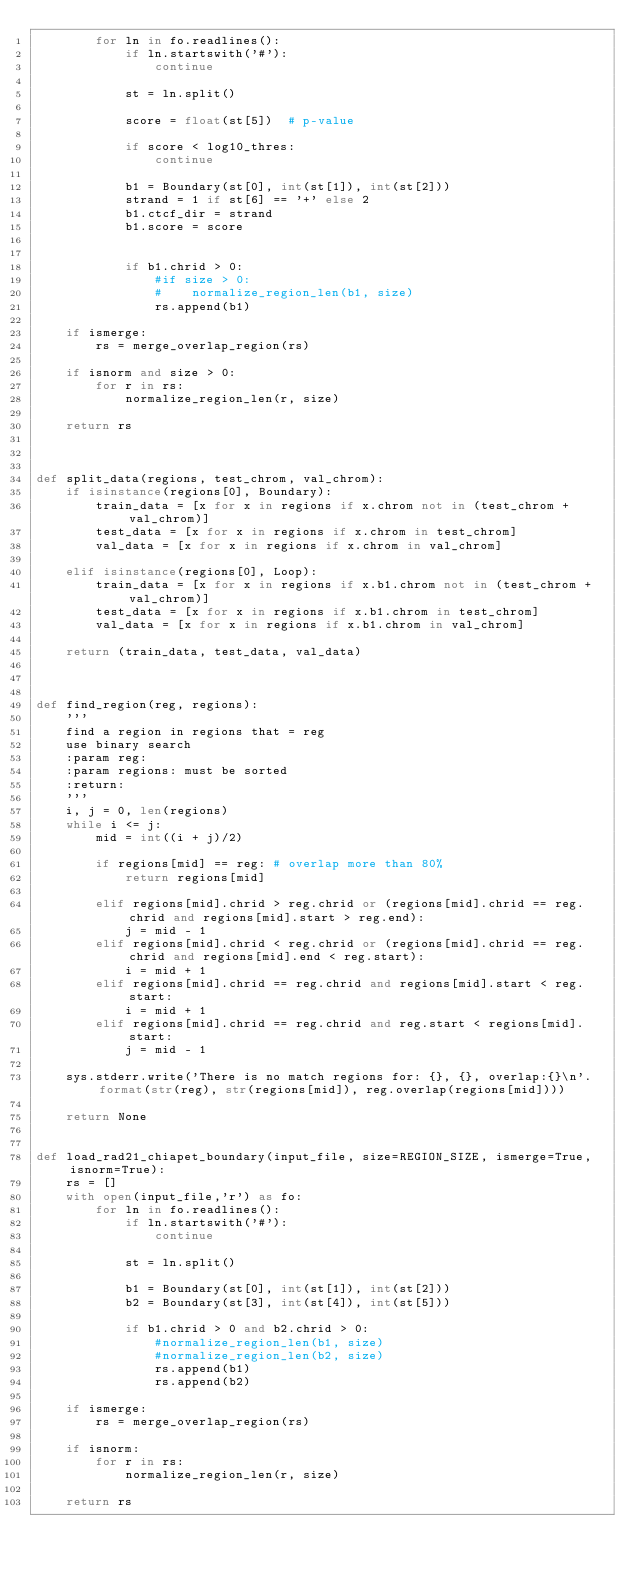<code> <loc_0><loc_0><loc_500><loc_500><_Python_>        for ln in fo.readlines():
            if ln.startswith('#'):
                continue

            st = ln.split()

            score = float(st[5])  # p-value

            if score < log10_thres:
                continue

            b1 = Boundary(st[0], int(st[1]), int(st[2]))
            strand = 1 if st[6] == '+' else 2
            b1.ctcf_dir = strand
            b1.score = score


            if b1.chrid > 0:
                #if size > 0:
                #    normalize_region_len(b1, size)
                rs.append(b1)

    if ismerge:
        rs = merge_overlap_region(rs)

    if isnorm and size > 0:
        for r in rs:
            normalize_region_len(r, size)

    return rs



def split_data(regions, test_chrom, val_chrom):
    if isinstance(regions[0], Boundary):
        train_data = [x for x in regions if x.chrom not in (test_chrom + val_chrom)]
        test_data = [x for x in regions if x.chrom in test_chrom]
        val_data = [x for x in regions if x.chrom in val_chrom]

    elif isinstance(regions[0], Loop):
        train_data = [x for x in regions if x.b1.chrom not in (test_chrom + val_chrom)]
        test_data = [x for x in regions if x.b1.chrom in test_chrom]
        val_data = [x for x in regions if x.b1.chrom in val_chrom]

    return (train_data, test_data, val_data)



def find_region(reg, regions):
    '''
    find a region in regions that = reg
    use binary search
    :param reg:
    :param regions: must be sorted
    :return:
    '''
    i, j = 0, len(regions)
    while i <= j:
        mid = int((i + j)/2)

        if regions[mid] == reg: # overlap more than 80%
            return regions[mid]

        elif regions[mid].chrid > reg.chrid or (regions[mid].chrid == reg.chrid and regions[mid].start > reg.end):
            j = mid - 1
        elif regions[mid].chrid < reg.chrid or (regions[mid].chrid == reg.chrid and regions[mid].end < reg.start):
            i = mid + 1
        elif regions[mid].chrid == reg.chrid and regions[mid].start < reg.start:
            i = mid + 1
        elif regions[mid].chrid == reg.chrid and reg.start < regions[mid].start:
            j = mid - 1

    sys.stderr.write('There is no match regions for: {}, {}, overlap:{}\n'.format(str(reg), str(regions[mid]), reg.overlap(regions[mid])))

    return None


def load_rad21_chiapet_boundary(input_file, size=REGION_SIZE, ismerge=True, isnorm=True):
    rs = []
    with open(input_file,'r') as fo:
        for ln in fo.readlines():
            if ln.startswith('#'):
                continue

            st = ln.split()

            b1 = Boundary(st[0], int(st[1]), int(st[2]))
            b2 = Boundary(st[3], int(st[4]), int(st[5]))

            if b1.chrid > 0 and b2.chrid > 0:
                #normalize_region_len(b1, size)
                #normalize_region_len(b2, size)
                rs.append(b1)
                rs.append(b2)

    if ismerge:
        rs = merge_overlap_region(rs)

    if isnorm:
        for r in rs:
            normalize_region_len(r, size)

    return rs
</code> 